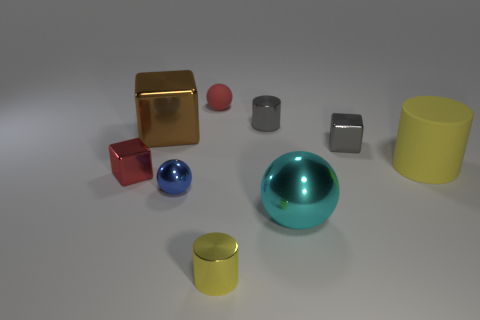Add 9 purple metal blocks. How many purple metal blocks exist? 9 Add 1 gray shiny cylinders. How many objects exist? 10 Subtract all yellow cylinders. How many cylinders are left? 1 Subtract all small gray cylinders. How many cylinders are left? 2 Subtract 0 red cylinders. How many objects are left? 9 Subtract all balls. How many objects are left? 6 Subtract 3 spheres. How many spheres are left? 0 Subtract all cyan cylinders. Subtract all gray balls. How many cylinders are left? 3 Subtract all yellow balls. How many brown blocks are left? 1 Subtract all yellow matte objects. Subtract all brown shiny blocks. How many objects are left? 7 